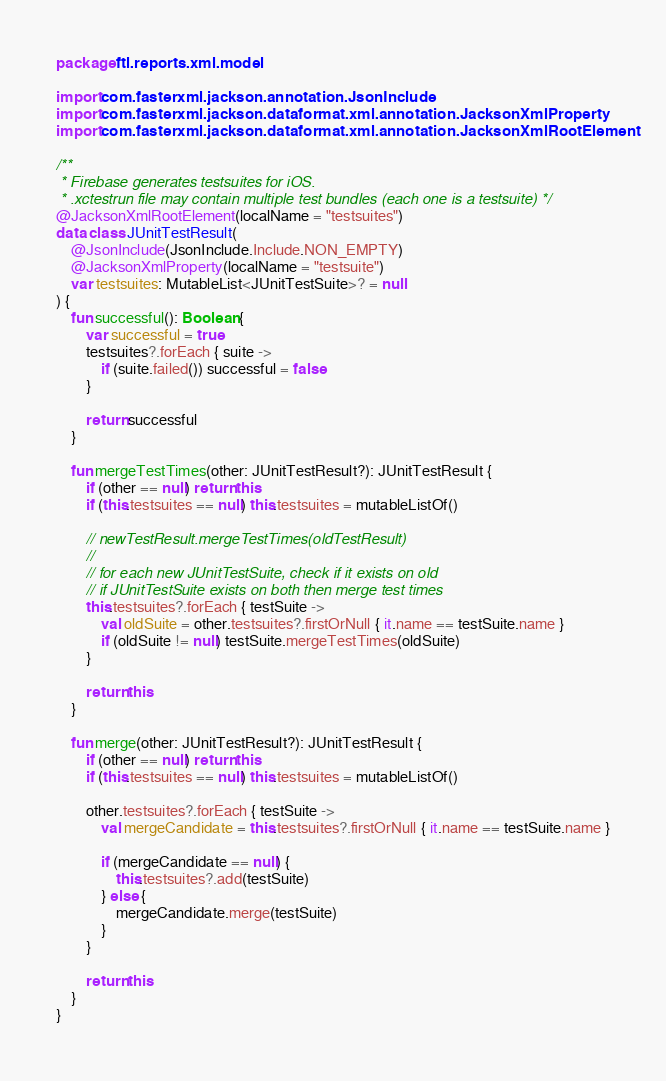Convert code to text. <code><loc_0><loc_0><loc_500><loc_500><_Kotlin_>package ftl.reports.xml.model

import com.fasterxml.jackson.annotation.JsonInclude
import com.fasterxml.jackson.dataformat.xml.annotation.JacksonXmlProperty
import com.fasterxml.jackson.dataformat.xml.annotation.JacksonXmlRootElement

/**
 * Firebase generates testsuites for iOS.
 * .xctestrun file may contain multiple test bundles (each one is a testsuite) */
@JacksonXmlRootElement(localName = "testsuites")
data class JUnitTestResult(
    @JsonInclude(JsonInclude.Include.NON_EMPTY)
    @JacksonXmlProperty(localName = "testsuite")
    var testsuites: MutableList<JUnitTestSuite>? = null
) {
    fun successful(): Boolean {
        var successful = true
        testsuites?.forEach { suite ->
            if (suite.failed()) successful = false
        }

        return successful
    }

    fun mergeTestTimes(other: JUnitTestResult?): JUnitTestResult {
        if (other == null) return this
        if (this.testsuites == null) this.testsuites = mutableListOf()

        // newTestResult.mergeTestTimes(oldTestResult)
        //
        // for each new JUnitTestSuite, check if it exists on old
        // if JUnitTestSuite exists on both then merge test times
        this.testsuites?.forEach { testSuite ->
            val oldSuite = other.testsuites?.firstOrNull { it.name == testSuite.name }
            if (oldSuite != null) testSuite.mergeTestTimes(oldSuite)
        }

        return this
    }

    fun merge(other: JUnitTestResult?): JUnitTestResult {
        if (other == null) return this
        if (this.testsuites == null) this.testsuites = mutableListOf()

        other.testsuites?.forEach { testSuite ->
            val mergeCandidate = this.testsuites?.firstOrNull { it.name == testSuite.name }

            if (mergeCandidate == null) {
                this.testsuites?.add(testSuite)
            } else {
                mergeCandidate.merge(testSuite)
            }
        }

        return this
    }
}
</code> 